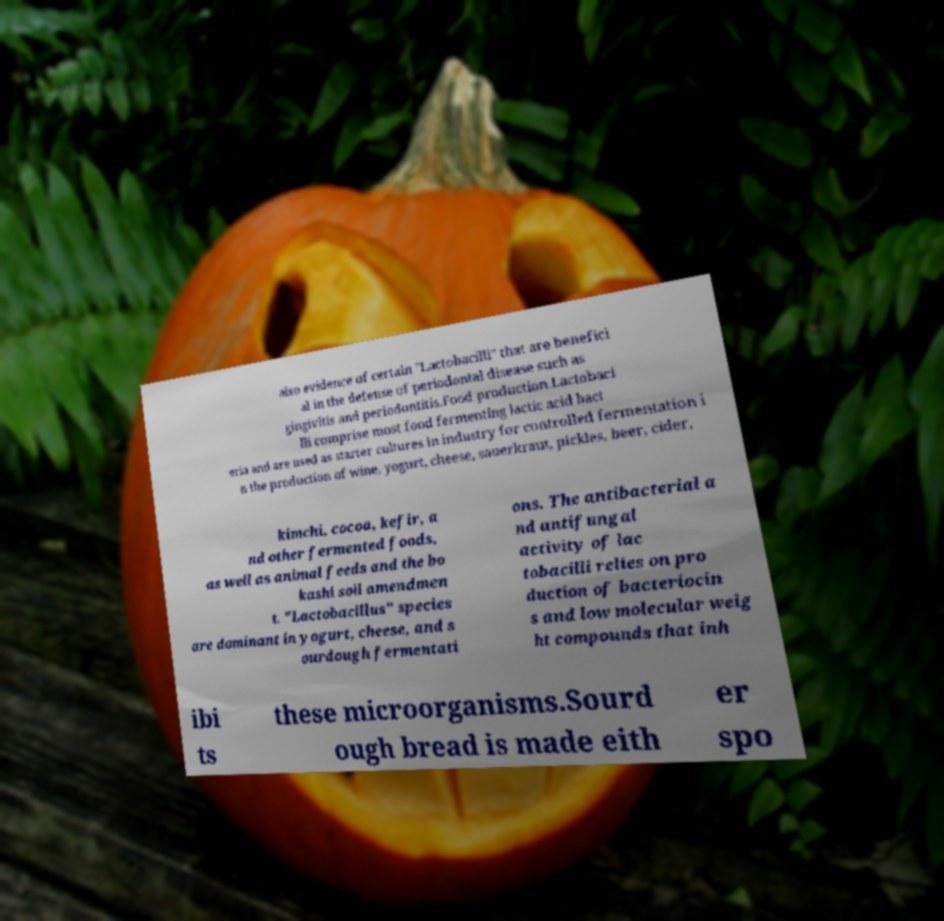Please read and relay the text visible in this image. What does it say? also evidence of certain "Lactobacilli" that are benefici al in the defense of periodontal disease such as gingivitis and periodontitis.Food production.Lactobaci lli comprise most food fermenting lactic acid bact eria and are used as starter cultures in industry for controlled fermentation i n the production of wine, yogurt, cheese, sauerkraut, pickles, beer, cider, kimchi, cocoa, kefir, a nd other fermented foods, as well as animal feeds and the bo kashi soil amendmen t. "Lactobacillus" species are dominant in yogurt, cheese, and s ourdough fermentati ons. The antibacterial a nd antifungal activity of lac tobacilli relies on pro duction of bacteriocin s and low molecular weig ht compounds that inh ibi ts these microorganisms.Sourd ough bread is made eith er spo 